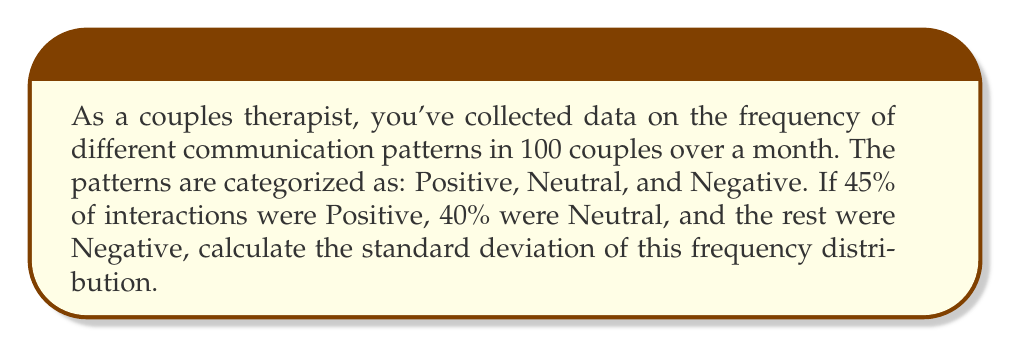Solve this math problem. To calculate the standard deviation, we'll follow these steps:

1) First, let's identify our data:
   Positive: 45%
   Neutral: 40%
   Negative: 15% (100% - 45% - 40%)

2) Calculate the mean (μ):
   $$ \mu = \frac{45 + 40 + 15}{3} = \frac{100}{3} \approx 33.33\% $$

3) Calculate the squared differences from the mean:
   Positive: $(45 - 33.33)^2 = 11.67^2 = 136.19$
   Neutral: $(40 - 33.33)^2 = 6.67^2 = 44.49$
   Negative: $(15 - 33.33)^2 = (-18.33)^2 = 335.99$

4) Calculate the variance (σ²):
   $$ \sigma^2 = \frac{136.19 + 44.49 + 335.99}{3} = \frac{516.67}{3} \approx 172.22 $$

5) Calculate the standard deviation (σ) by taking the square root of the variance:
   $$ \sigma = \sqrt{172.22} \approx 13.12\% $$
Answer: 13.12% 